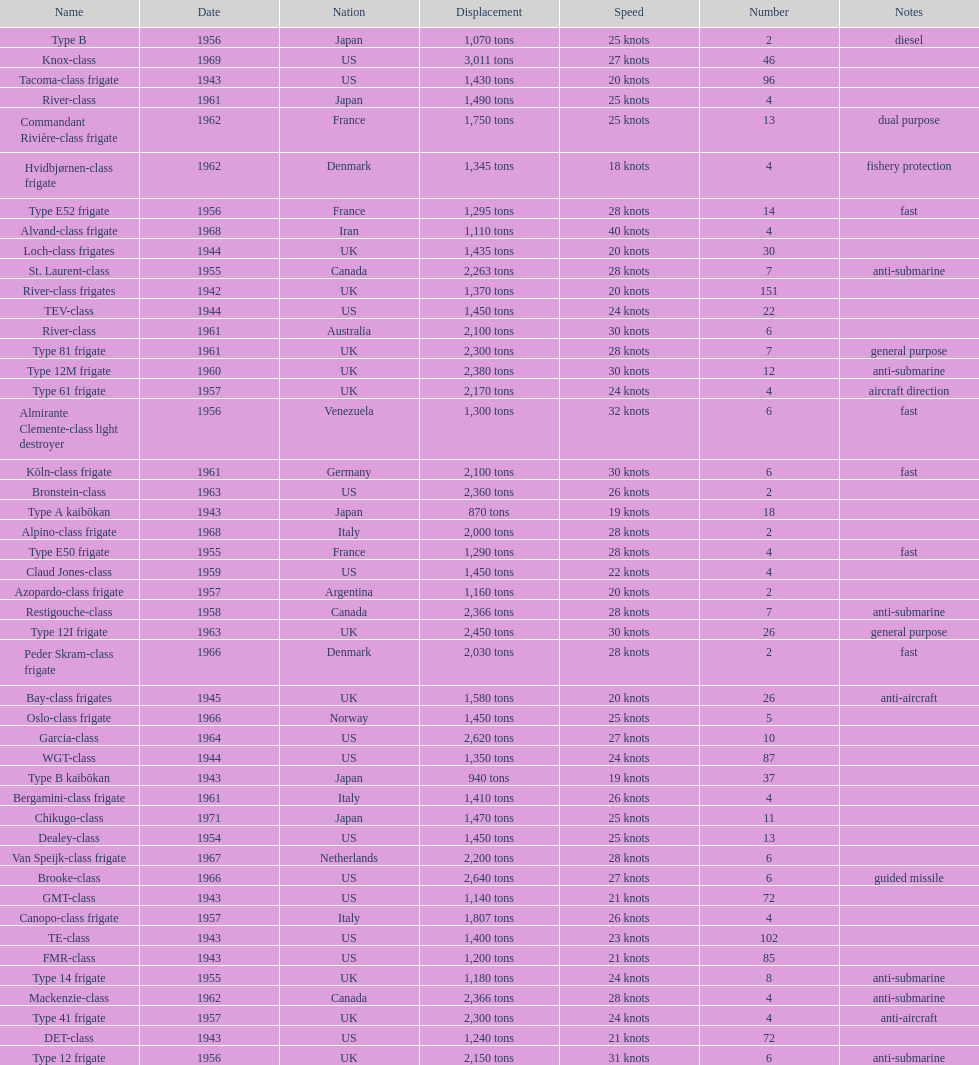In 1968, what was the maximum speed of the alpino-class frigate used by italy? 28 knots. 